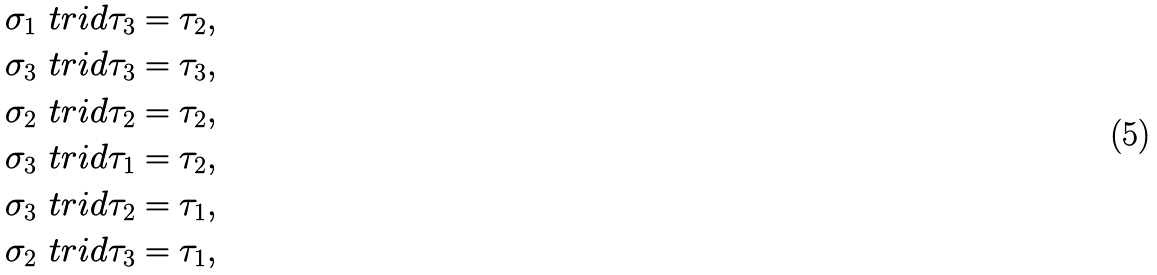Convert formula to latex. <formula><loc_0><loc_0><loc_500><loc_500>\sigma _ { 1 } \ t r i d \tau _ { 3 } & = \tau _ { 2 } , \\ \sigma _ { 3 } \ t r i d \tau _ { 3 } & = \tau _ { 3 } , \\ \sigma _ { 2 } \ t r i d \tau _ { 2 } & = \tau _ { 2 } , \\ \sigma _ { 3 } \ t r i d \tau _ { 1 } & = \tau _ { 2 } , \\ \sigma _ { 3 } \ t r i d \tau _ { 2 } & = \tau _ { 1 } , \\ \sigma _ { 2 } \ t r i d \tau _ { 3 } & = \tau _ { 1 } ,</formula> 